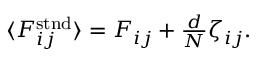<formula> <loc_0><loc_0><loc_500><loc_500>\begin{array} { r } { \langle F _ { i j } ^ { s t n d } \rangle = F _ { i j } + \frac { d } { N } \zeta _ { i j } . } \end{array}</formula> 